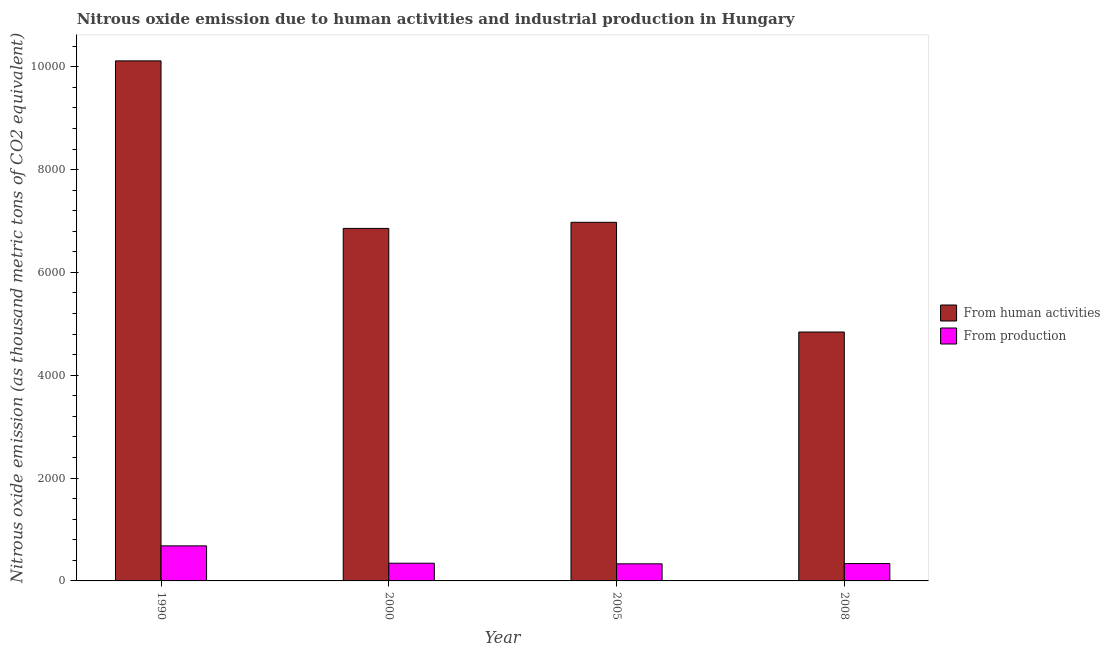How many different coloured bars are there?
Ensure brevity in your answer.  2. How many groups of bars are there?
Provide a succinct answer. 4. How many bars are there on the 3rd tick from the left?
Your answer should be very brief. 2. How many bars are there on the 3rd tick from the right?
Make the answer very short. 2. What is the amount of emissions from human activities in 2008?
Offer a very short reply. 4840.8. Across all years, what is the maximum amount of emissions generated from industries?
Offer a terse response. 681.7. Across all years, what is the minimum amount of emissions from human activities?
Your answer should be very brief. 4840.8. In which year was the amount of emissions from human activities maximum?
Keep it short and to the point. 1990. What is the total amount of emissions from human activities in the graph?
Keep it short and to the point. 2.88e+04. What is the difference between the amount of emissions from human activities in 2005 and that in 2008?
Your answer should be compact. 2133.8. What is the difference between the amount of emissions from human activities in 1990 and the amount of emissions generated from industries in 2005?
Offer a very short reply. 3139.6. What is the average amount of emissions from human activities per year?
Keep it short and to the point. 7196.35. In the year 1990, what is the difference between the amount of emissions from human activities and amount of emissions generated from industries?
Make the answer very short. 0. What is the ratio of the amount of emissions generated from industries in 2000 to that in 2005?
Your answer should be compact. 1.04. Is the amount of emissions from human activities in 1990 less than that in 2000?
Provide a succinct answer. No. Is the difference between the amount of emissions from human activities in 1990 and 2008 greater than the difference between the amount of emissions generated from industries in 1990 and 2008?
Keep it short and to the point. No. What is the difference between the highest and the second highest amount of emissions generated from industries?
Ensure brevity in your answer.  337.2. What is the difference between the highest and the lowest amount of emissions generated from industries?
Provide a short and direct response. 349.1. What does the 1st bar from the left in 2008 represents?
Provide a short and direct response. From human activities. What does the 1st bar from the right in 2000 represents?
Keep it short and to the point. From production. How many bars are there?
Keep it short and to the point. 8. Does the graph contain any zero values?
Keep it short and to the point. No. Does the graph contain grids?
Make the answer very short. No. How are the legend labels stacked?
Your answer should be compact. Vertical. What is the title of the graph?
Your response must be concise. Nitrous oxide emission due to human activities and industrial production in Hungary. Does "Current education expenditure" appear as one of the legend labels in the graph?
Your answer should be compact. No. What is the label or title of the X-axis?
Keep it short and to the point. Year. What is the label or title of the Y-axis?
Your answer should be very brief. Nitrous oxide emission (as thousand metric tons of CO2 equivalent). What is the Nitrous oxide emission (as thousand metric tons of CO2 equivalent) in From human activities in 1990?
Make the answer very short. 1.01e+04. What is the Nitrous oxide emission (as thousand metric tons of CO2 equivalent) of From production in 1990?
Make the answer very short. 681.7. What is the Nitrous oxide emission (as thousand metric tons of CO2 equivalent) in From human activities in 2000?
Offer a very short reply. 6855.8. What is the Nitrous oxide emission (as thousand metric tons of CO2 equivalent) in From production in 2000?
Offer a terse response. 344.5. What is the Nitrous oxide emission (as thousand metric tons of CO2 equivalent) in From human activities in 2005?
Your response must be concise. 6974.6. What is the Nitrous oxide emission (as thousand metric tons of CO2 equivalent) in From production in 2005?
Keep it short and to the point. 332.6. What is the Nitrous oxide emission (as thousand metric tons of CO2 equivalent) in From human activities in 2008?
Keep it short and to the point. 4840.8. What is the Nitrous oxide emission (as thousand metric tons of CO2 equivalent) of From production in 2008?
Your answer should be compact. 337.9. Across all years, what is the maximum Nitrous oxide emission (as thousand metric tons of CO2 equivalent) of From human activities?
Ensure brevity in your answer.  1.01e+04. Across all years, what is the maximum Nitrous oxide emission (as thousand metric tons of CO2 equivalent) in From production?
Keep it short and to the point. 681.7. Across all years, what is the minimum Nitrous oxide emission (as thousand metric tons of CO2 equivalent) in From human activities?
Your answer should be compact. 4840.8. Across all years, what is the minimum Nitrous oxide emission (as thousand metric tons of CO2 equivalent) in From production?
Offer a terse response. 332.6. What is the total Nitrous oxide emission (as thousand metric tons of CO2 equivalent) in From human activities in the graph?
Give a very brief answer. 2.88e+04. What is the total Nitrous oxide emission (as thousand metric tons of CO2 equivalent) of From production in the graph?
Make the answer very short. 1696.7. What is the difference between the Nitrous oxide emission (as thousand metric tons of CO2 equivalent) in From human activities in 1990 and that in 2000?
Make the answer very short. 3258.4. What is the difference between the Nitrous oxide emission (as thousand metric tons of CO2 equivalent) of From production in 1990 and that in 2000?
Give a very brief answer. 337.2. What is the difference between the Nitrous oxide emission (as thousand metric tons of CO2 equivalent) of From human activities in 1990 and that in 2005?
Provide a short and direct response. 3139.6. What is the difference between the Nitrous oxide emission (as thousand metric tons of CO2 equivalent) in From production in 1990 and that in 2005?
Your answer should be very brief. 349.1. What is the difference between the Nitrous oxide emission (as thousand metric tons of CO2 equivalent) of From human activities in 1990 and that in 2008?
Keep it short and to the point. 5273.4. What is the difference between the Nitrous oxide emission (as thousand metric tons of CO2 equivalent) of From production in 1990 and that in 2008?
Give a very brief answer. 343.8. What is the difference between the Nitrous oxide emission (as thousand metric tons of CO2 equivalent) of From human activities in 2000 and that in 2005?
Offer a terse response. -118.8. What is the difference between the Nitrous oxide emission (as thousand metric tons of CO2 equivalent) in From production in 2000 and that in 2005?
Make the answer very short. 11.9. What is the difference between the Nitrous oxide emission (as thousand metric tons of CO2 equivalent) of From human activities in 2000 and that in 2008?
Your response must be concise. 2015. What is the difference between the Nitrous oxide emission (as thousand metric tons of CO2 equivalent) in From production in 2000 and that in 2008?
Offer a terse response. 6.6. What is the difference between the Nitrous oxide emission (as thousand metric tons of CO2 equivalent) of From human activities in 2005 and that in 2008?
Your response must be concise. 2133.8. What is the difference between the Nitrous oxide emission (as thousand metric tons of CO2 equivalent) in From human activities in 1990 and the Nitrous oxide emission (as thousand metric tons of CO2 equivalent) in From production in 2000?
Offer a very short reply. 9769.7. What is the difference between the Nitrous oxide emission (as thousand metric tons of CO2 equivalent) in From human activities in 1990 and the Nitrous oxide emission (as thousand metric tons of CO2 equivalent) in From production in 2005?
Provide a short and direct response. 9781.6. What is the difference between the Nitrous oxide emission (as thousand metric tons of CO2 equivalent) in From human activities in 1990 and the Nitrous oxide emission (as thousand metric tons of CO2 equivalent) in From production in 2008?
Give a very brief answer. 9776.3. What is the difference between the Nitrous oxide emission (as thousand metric tons of CO2 equivalent) in From human activities in 2000 and the Nitrous oxide emission (as thousand metric tons of CO2 equivalent) in From production in 2005?
Give a very brief answer. 6523.2. What is the difference between the Nitrous oxide emission (as thousand metric tons of CO2 equivalent) in From human activities in 2000 and the Nitrous oxide emission (as thousand metric tons of CO2 equivalent) in From production in 2008?
Your answer should be very brief. 6517.9. What is the difference between the Nitrous oxide emission (as thousand metric tons of CO2 equivalent) in From human activities in 2005 and the Nitrous oxide emission (as thousand metric tons of CO2 equivalent) in From production in 2008?
Offer a very short reply. 6636.7. What is the average Nitrous oxide emission (as thousand metric tons of CO2 equivalent) of From human activities per year?
Your answer should be very brief. 7196.35. What is the average Nitrous oxide emission (as thousand metric tons of CO2 equivalent) of From production per year?
Ensure brevity in your answer.  424.18. In the year 1990, what is the difference between the Nitrous oxide emission (as thousand metric tons of CO2 equivalent) of From human activities and Nitrous oxide emission (as thousand metric tons of CO2 equivalent) of From production?
Provide a short and direct response. 9432.5. In the year 2000, what is the difference between the Nitrous oxide emission (as thousand metric tons of CO2 equivalent) of From human activities and Nitrous oxide emission (as thousand metric tons of CO2 equivalent) of From production?
Provide a succinct answer. 6511.3. In the year 2005, what is the difference between the Nitrous oxide emission (as thousand metric tons of CO2 equivalent) of From human activities and Nitrous oxide emission (as thousand metric tons of CO2 equivalent) of From production?
Your answer should be very brief. 6642. In the year 2008, what is the difference between the Nitrous oxide emission (as thousand metric tons of CO2 equivalent) of From human activities and Nitrous oxide emission (as thousand metric tons of CO2 equivalent) of From production?
Your response must be concise. 4502.9. What is the ratio of the Nitrous oxide emission (as thousand metric tons of CO2 equivalent) in From human activities in 1990 to that in 2000?
Ensure brevity in your answer.  1.48. What is the ratio of the Nitrous oxide emission (as thousand metric tons of CO2 equivalent) of From production in 1990 to that in 2000?
Keep it short and to the point. 1.98. What is the ratio of the Nitrous oxide emission (as thousand metric tons of CO2 equivalent) in From human activities in 1990 to that in 2005?
Offer a very short reply. 1.45. What is the ratio of the Nitrous oxide emission (as thousand metric tons of CO2 equivalent) of From production in 1990 to that in 2005?
Provide a succinct answer. 2.05. What is the ratio of the Nitrous oxide emission (as thousand metric tons of CO2 equivalent) of From human activities in 1990 to that in 2008?
Your answer should be compact. 2.09. What is the ratio of the Nitrous oxide emission (as thousand metric tons of CO2 equivalent) in From production in 1990 to that in 2008?
Offer a very short reply. 2.02. What is the ratio of the Nitrous oxide emission (as thousand metric tons of CO2 equivalent) in From production in 2000 to that in 2005?
Offer a terse response. 1.04. What is the ratio of the Nitrous oxide emission (as thousand metric tons of CO2 equivalent) in From human activities in 2000 to that in 2008?
Provide a short and direct response. 1.42. What is the ratio of the Nitrous oxide emission (as thousand metric tons of CO2 equivalent) of From production in 2000 to that in 2008?
Provide a short and direct response. 1.02. What is the ratio of the Nitrous oxide emission (as thousand metric tons of CO2 equivalent) in From human activities in 2005 to that in 2008?
Provide a succinct answer. 1.44. What is the ratio of the Nitrous oxide emission (as thousand metric tons of CO2 equivalent) in From production in 2005 to that in 2008?
Your answer should be very brief. 0.98. What is the difference between the highest and the second highest Nitrous oxide emission (as thousand metric tons of CO2 equivalent) of From human activities?
Provide a short and direct response. 3139.6. What is the difference between the highest and the second highest Nitrous oxide emission (as thousand metric tons of CO2 equivalent) in From production?
Your response must be concise. 337.2. What is the difference between the highest and the lowest Nitrous oxide emission (as thousand metric tons of CO2 equivalent) in From human activities?
Provide a succinct answer. 5273.4. What is the difference between the highest and the lowest Nitrous oxide emission (as thousand metric tons of CO2 equivalent) in From production?
Give a very brief answer. 349.1. 